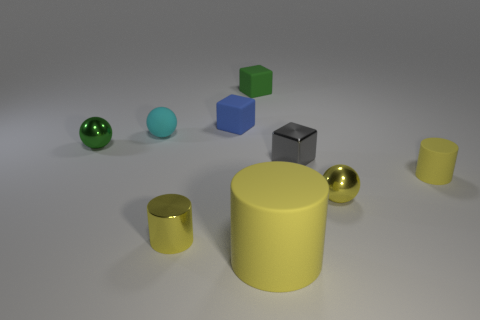Subtract all red cylinders. Subtract all cyan blocks. How many cylinders are left? 3 Subtract all cubes. How many objects are left? 6 Add 1 tiny objects. How many tiny objects are left? 9 Add 6 big blue shiny blocks. How many big blue shiny blocks exist? 6 Subtract 1 green cubes. How many objects are left? 8 Subtract all tiny spheres. Subtract all gray metal cubes. How many objects are left? 5 